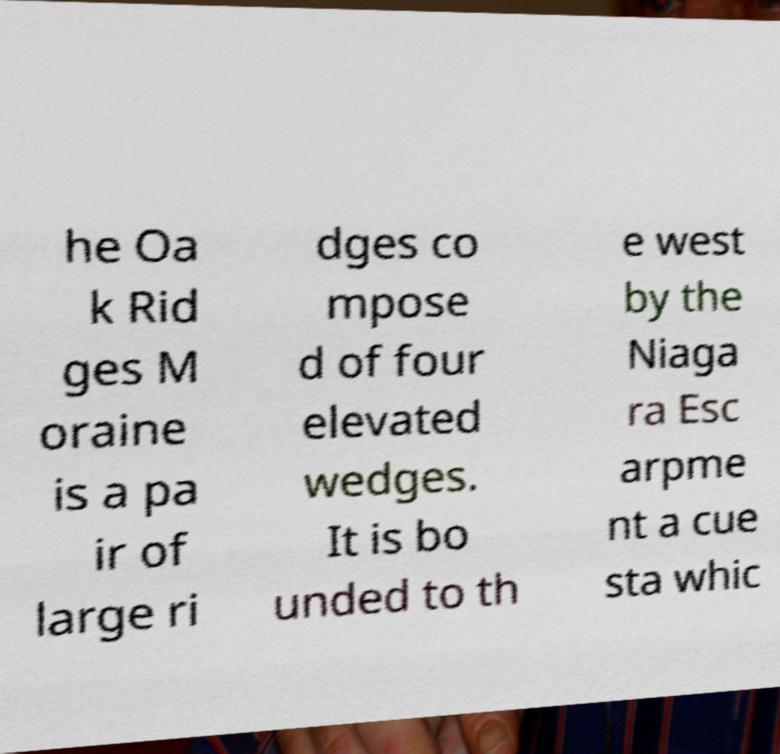I need the written content from this picture converted into text. Can you do that? he Oa k Rid ges M oraine is a pa ir of large ri dges co mpose d of four elevated wedges. It is bo unded to th e west by the Niaga ra Esc arpme nt a cue sta whic 